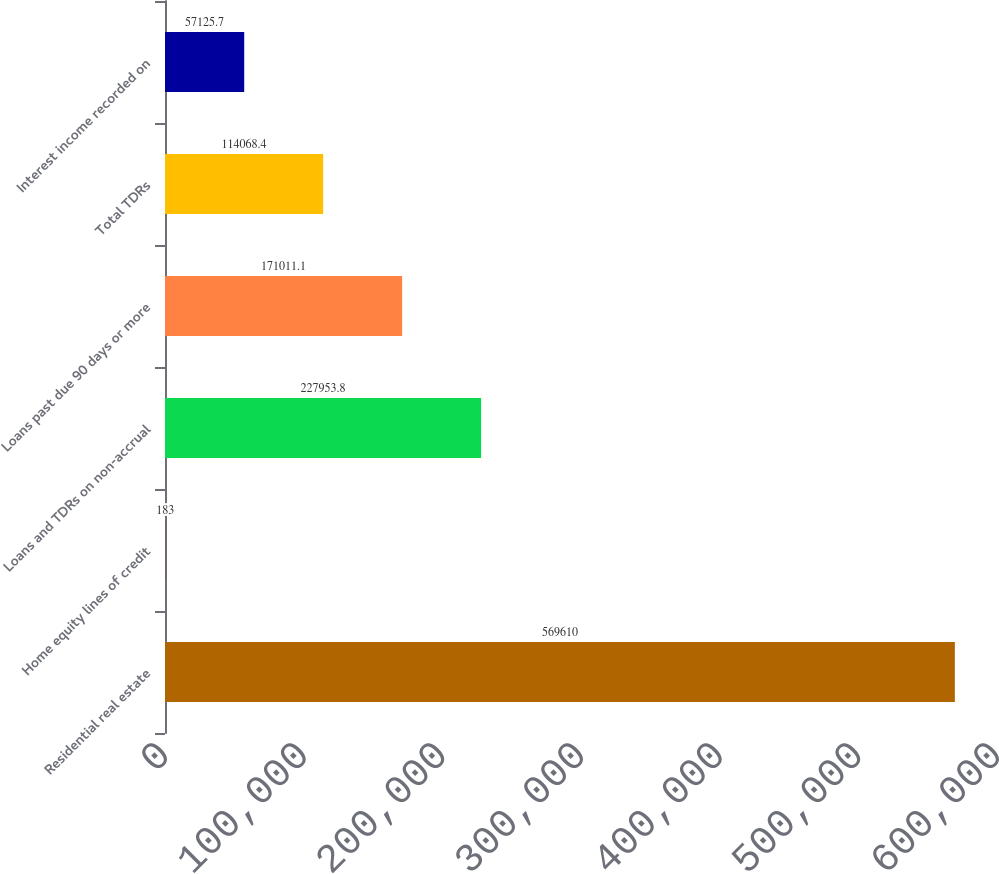<chart> <loc_0><loc_0><loc_500><loc_500><bar_chart><fcel>Residential real estate<fcel>Home equity lines of credit<fcel>Loans and TDRs on non-accrual<fcel>Loans past due 90 days or more<fcel>Total TDRs<fcel>Interest income recorded on<nl><fcel>569610<fcel>183<fcel>227954<fcel>171011<fcel>114068<fcel>57125.7<nl></chart> 